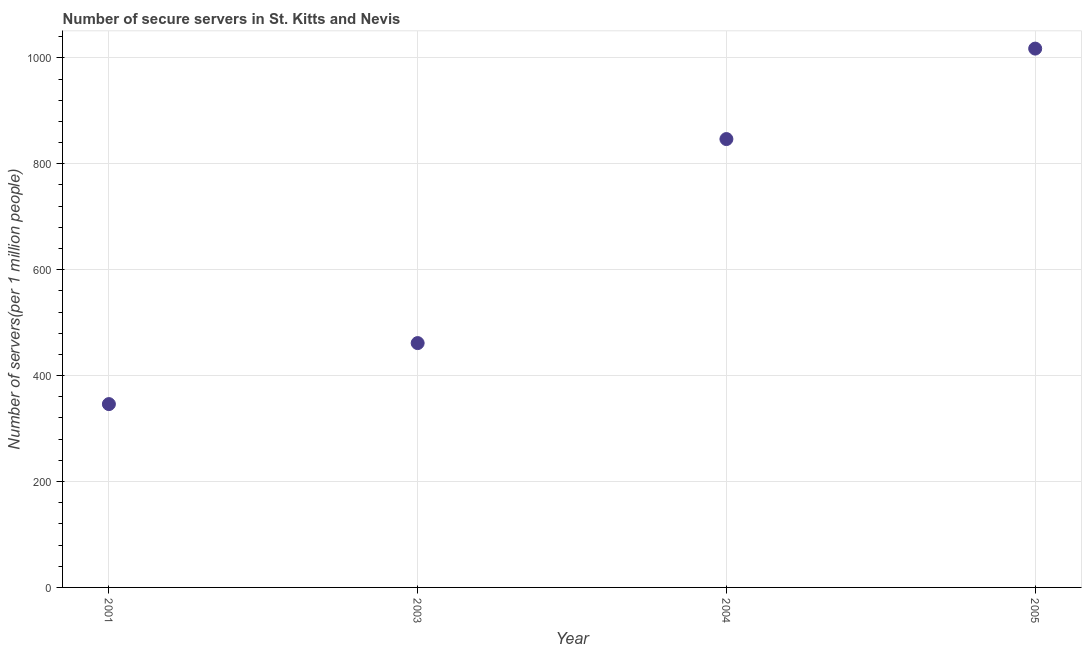What is the number of secure internet servers in 2004?
Keep it short and to the point. 846.69. Across all years, what is the maximum number of secure internet servers?
Provide a short and direct response. 1017.52. Across all years, what is the minimum number of secure internet servers?
Give a very brief answer. 346.2. In which year was the number of secure internet servers minimum?
Give a very brief answer. 2001. What is the sum of the number of secure internet servers?
Your answer should be compact. 2671.81. What is the difference between the number of secure internet servers in 2001 and 2003?
Your answer should be very brief. -115.2. What is the average number of secure internet servers per year?
Your answer should be compact. 667.95. What is the median number of secure internet servers?
Give a very brief answer. 654.04. What is the ratio of the number of secure internet servers in 2003 to that in 2005?
Provide a succinct answer. 0.45. Is the number of secure internet servers in 2003 less than that in 2005?
Provide a short and direct response. Yes. Is the difference between the number of secure internet servers in 2001 and 2004 greater than the difference between any two years?
Your answer should be very brief. No. What is the difference between the highest and the second highest number of secure internet servers?
Keep it short and to the point. 170.83. What is the difference between the highest and the lowest number of secure internet servers?
Offer a very short reply. 671.32. In how many years, is the number of secure internet servers greater than the average number of secure internet servers taken over all years?
Provide a succinct answer. 2. Does the number of secure internet servers monotonically increase over the years?
Your answer should be very brief. Yes. Are the values on the major ticks of Y-axis written in scientific E-notation?
Give a very brief answer. No. Does the graph contain any zero values?
Ensure brevity in your answer.  No. Does the graph contain grids?
Ensure brevity in your answer.  Yes. What is the title of the graph?
Give a very brief answer. Number of secure servers in St. Kitts and Nevis. What is the label or title of the X-axis?
Keep it short and to the point. Year. What is the label or title of the Y-axis?
Provide a short and direct response. Number of servers(per 1 million people). What is the Number of servers(per 1 million people) in 2001?
Keep it short and to the point. 346.2. What is the Number of servers(per 1 million people) in 2003?
Provide a succinct answer. 461.4. What is the Number of servers(per 1 million people) in 2004?
Make the answer very short. 846.69. What is the Number of servers(per 1 million people) in 2005?
Make the answer very short. 1017.52. What is the difference between the Number of servers(per 1 million people) in 2001 and 2003?
Your response must be concise. -115.2. What is the difference between the Number of servers(per 1 million people) in 2001 and 2004?
Provide a short and direct response. -500.49. What is the difference between the Number of servers(per 1 million people) in 2001 and 2005?
Your response must be concise. -671.32. What is the difference between the Number of servers(per 1 million people) in 2003 and 2004?
Your answer should be very brief. -385.29. What is the difference between the Number of servers(per 1 million people) in 2003 and 2005?
Make the answer very short. -556.12. What is the difference between the Number of servers(per 1 million people) in 2004 and 2005?
Keep it short and to the point. -170.83. What is the ratio of the Number of servers(per 1 million people) in 2001 to that in 2004?
Offer a very short reply. 0.41. What is the ratio of the Number of servers(per 1 million people) in 2001 to that in 2005?
Give a very brief answer. 0.34. What is the ratio of the Number of servers(per 1 million people) in 2003 to that in 2004?
Ensure brevity in your answer.  0.55. What is the ratio of the Number of servers(per 1 million people) in 2003 to that in 2005?
Keep it short and to the point. 0.45. What is the ratio of the Number of servers(per 1 million people) in 2004 to that in 2005?
Make the answer very short. 0.83. 